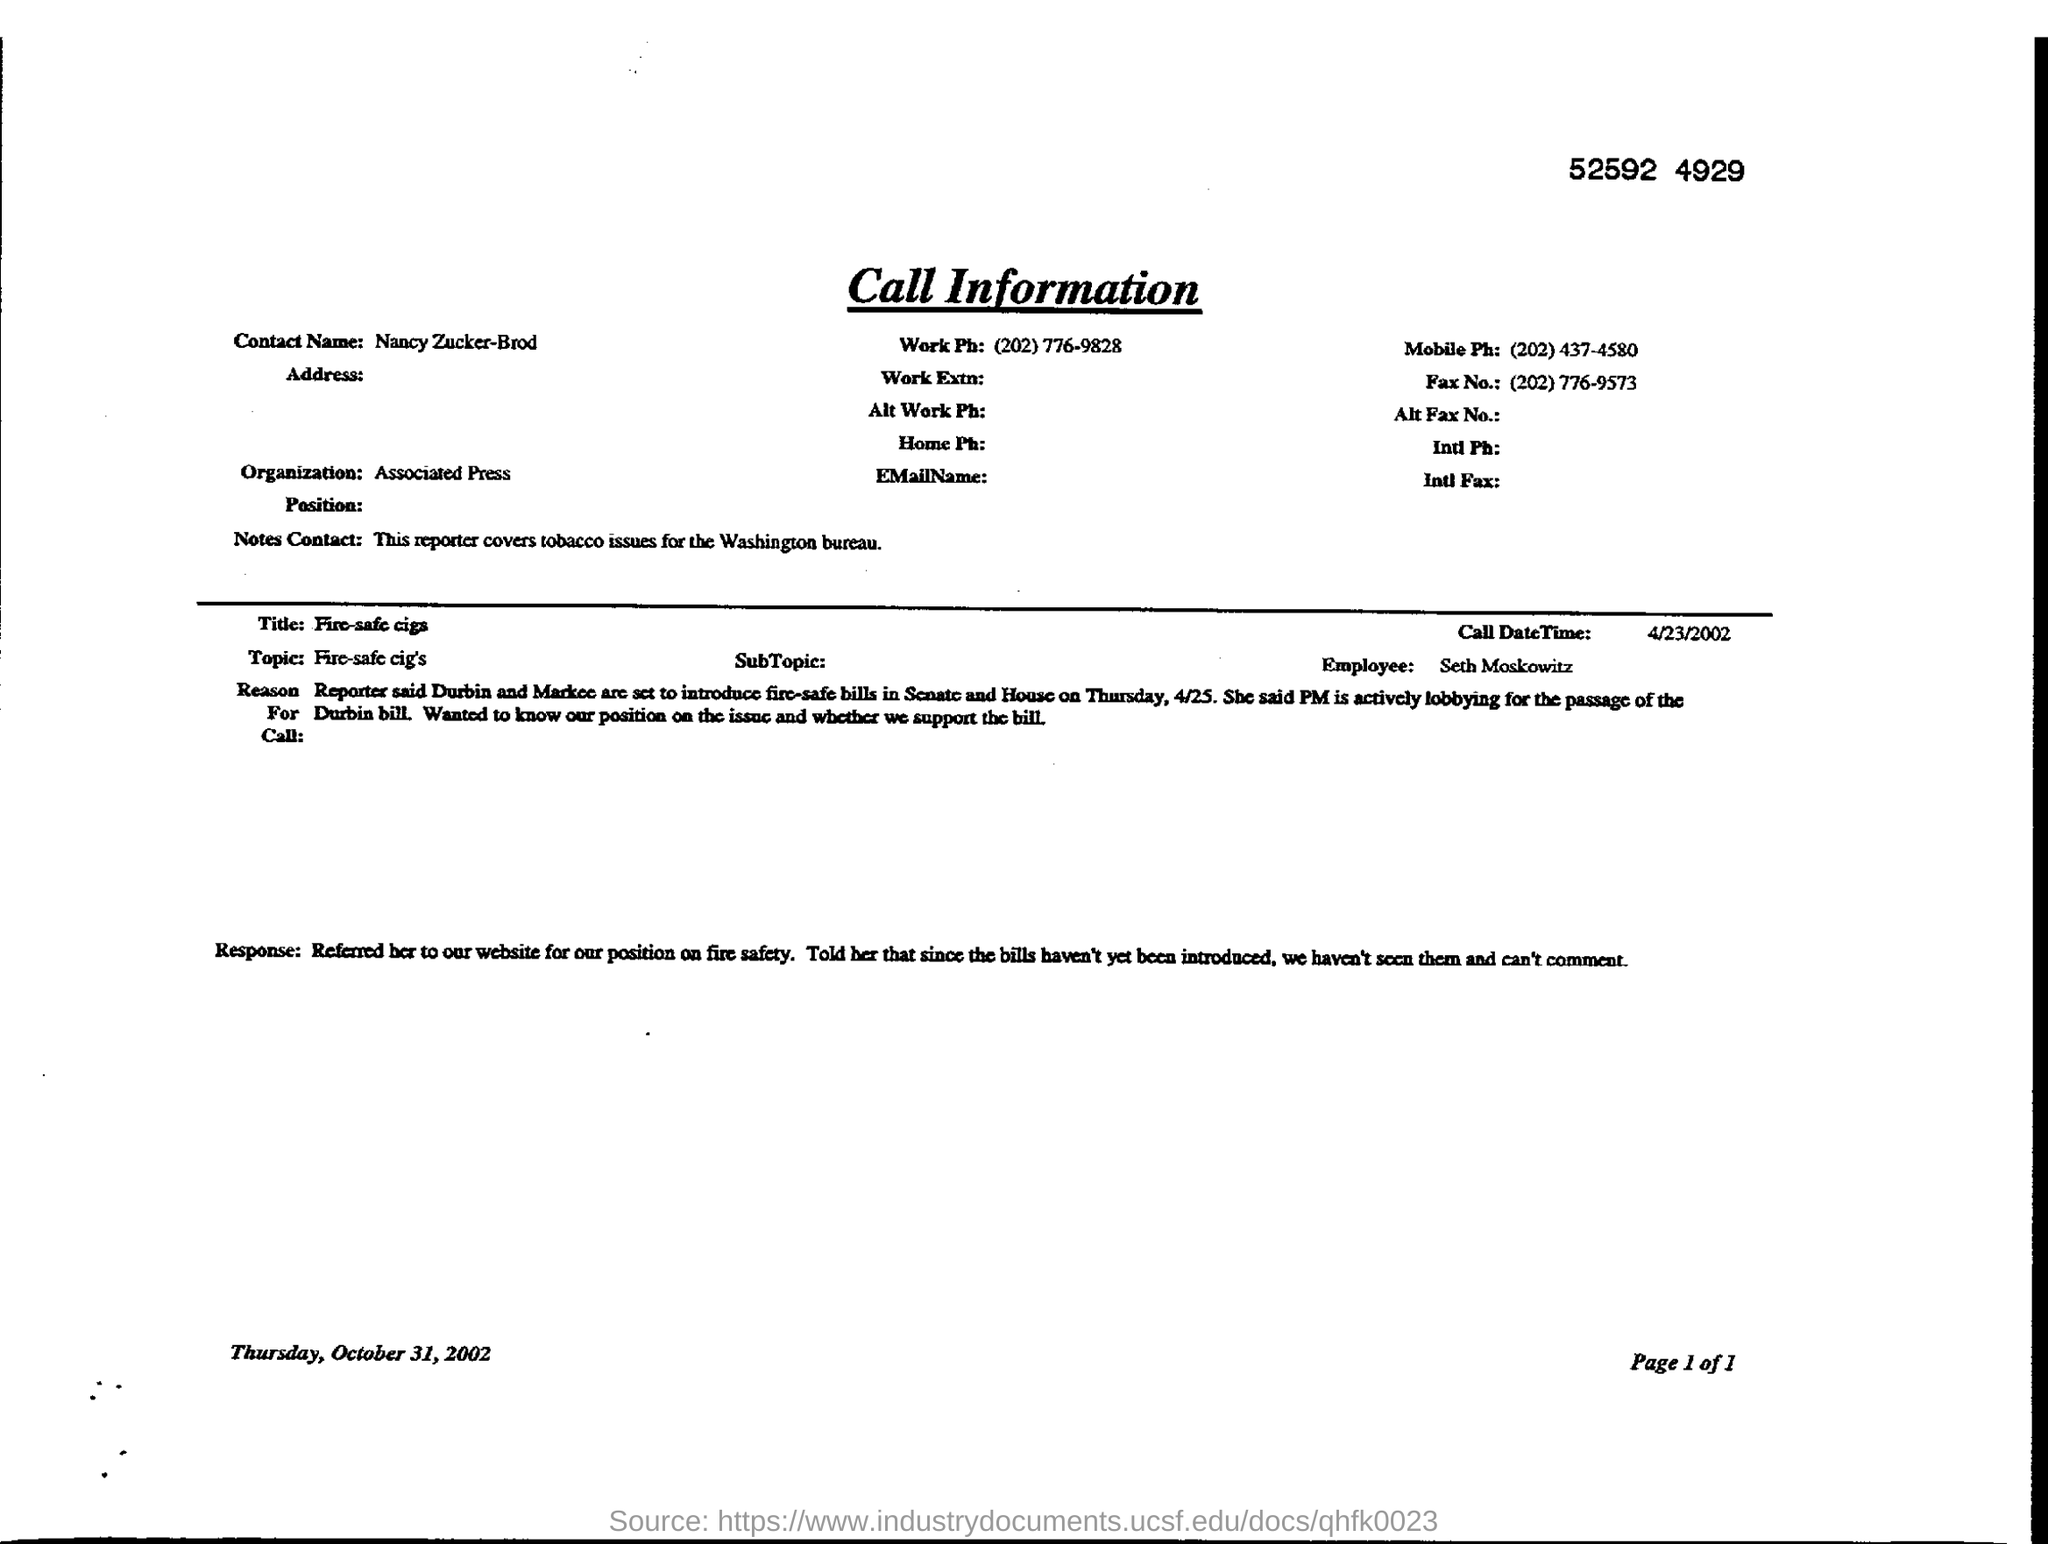Draw attention to some important aspects in this diagram. I, the person asking this question, require the fax number of Nancy Zucker-Brod, which is (202) 776-9573. The Associated Press is mentioned in the call information. The document contains the contact name "Nancy Zucker-Brod. Nancy Zucker-Brod covers a variety of issues for the Associated Press, including tobacco issues. What is the call date time given, specifically April 23, 2002? 